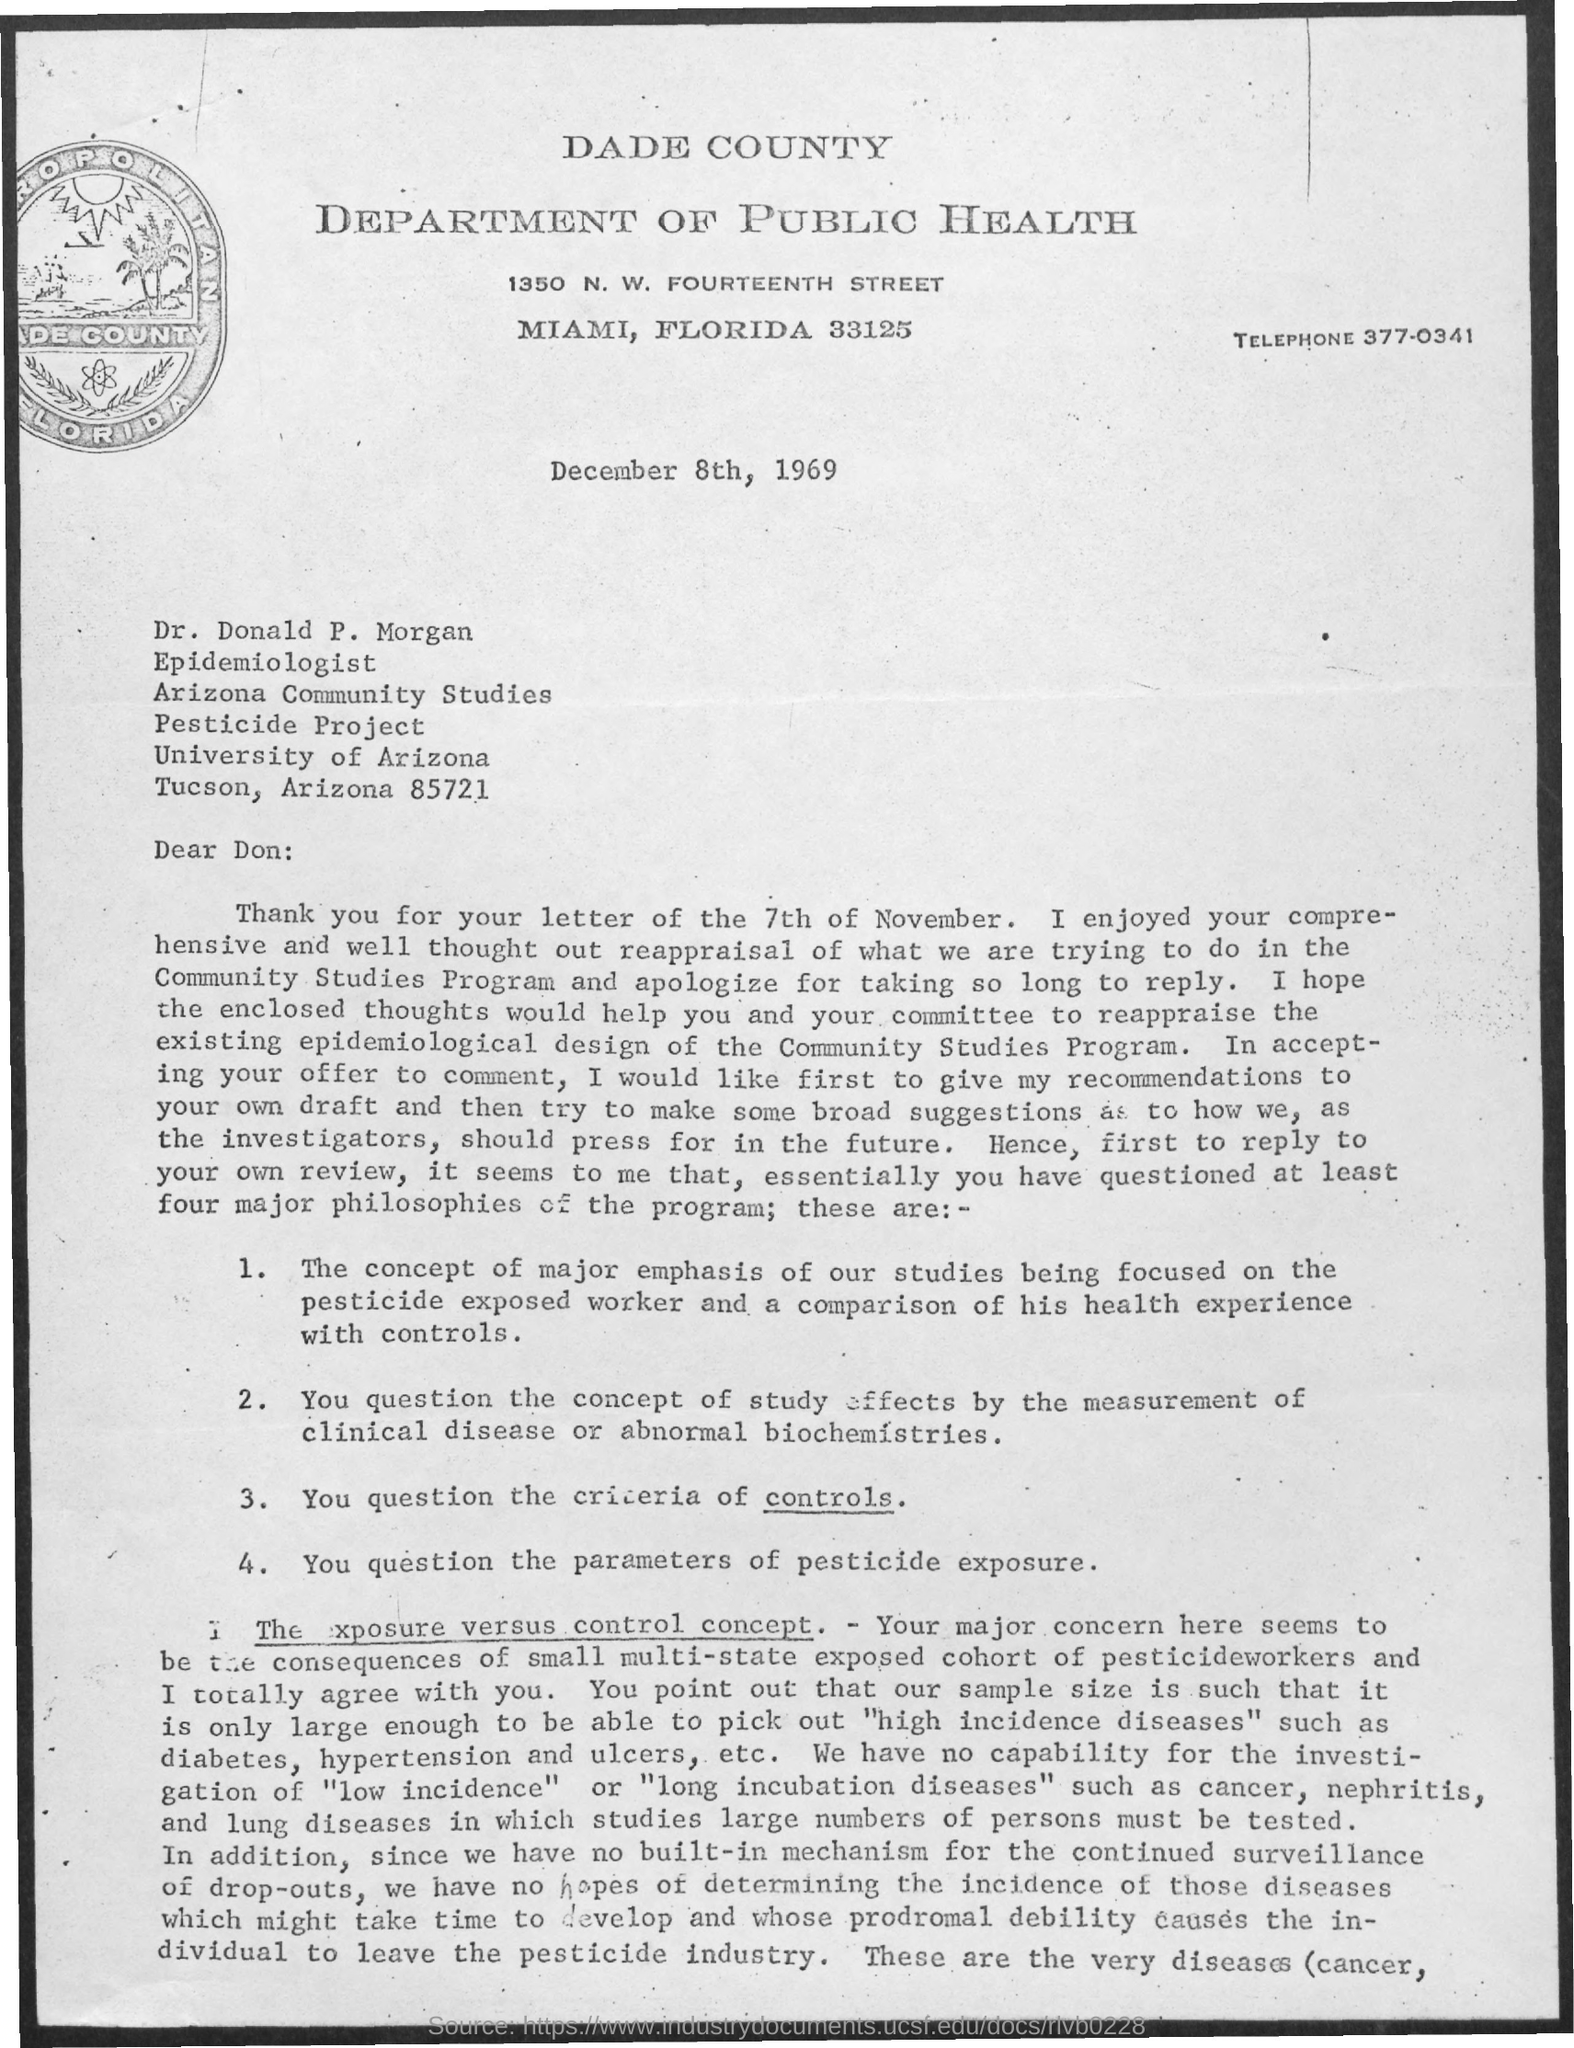What is the Telephone?
Your answer should be very brief. 377-0341. What is the Date?
Make the answer very short. December 8th, 1969. To whom is this letter addressed?
Keep it short and to the point. Dr. Donald P. Morgan. 